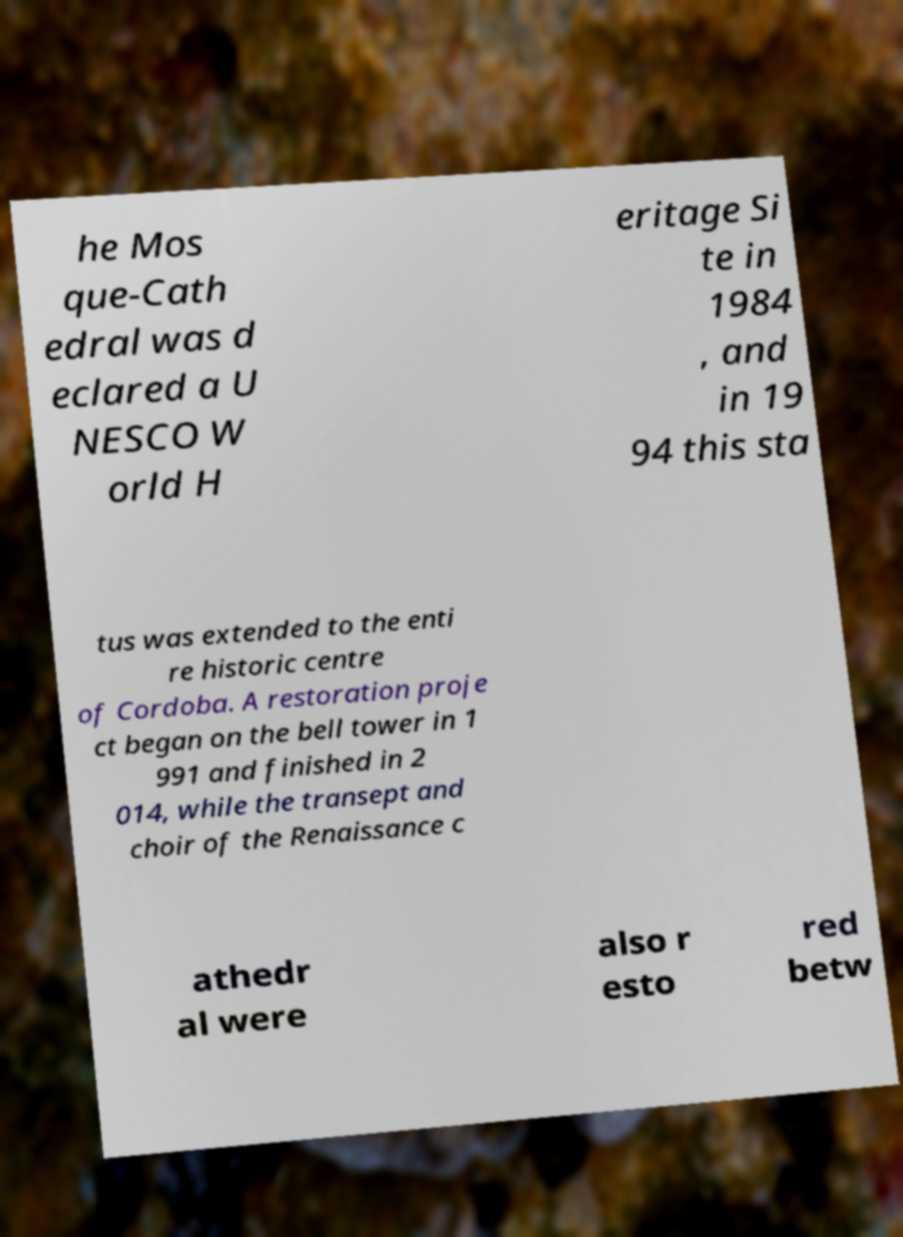What messages or text are displayed in this image? I need them in a readable, typed format. he Mos que-Cath edral was d eclared a U NESCO W orld H eritage Si te in 1984 , and in 19 94 this sta tus was extended to the enti re historic centre of Cordoba. A restoration proje ct began on the bell tower in 1 991 and finished in 2 014, while the transept and choir of the Renaissance c athedr al were also r esto red betw 